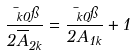<formula> <loc_0><loc_0><loc_500><loc_500>\frac { \mu _ { k 0 } \pi } { 2 \overline { A } _ { 2 k } } = \frac { \mu _ { k 0 } \pi } { 2 A _ { 1 k } } + 1</formula> 